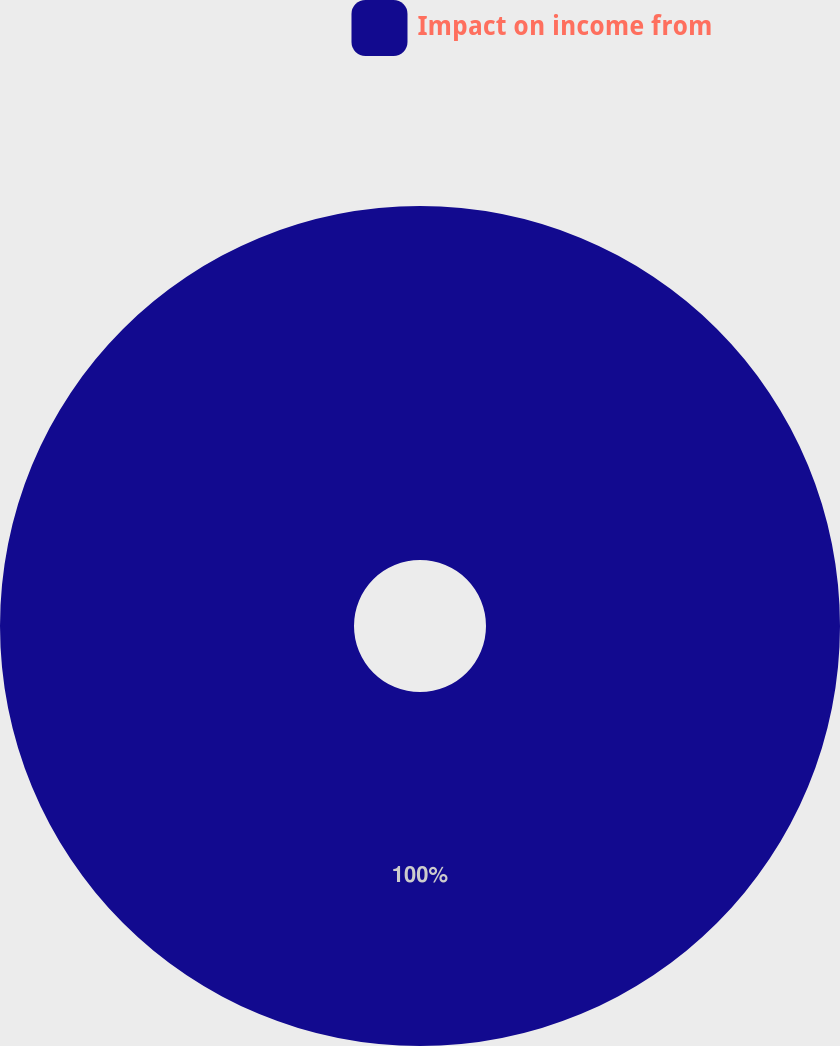Convert chart to OTSL. <chart><loc_0><loc_0><loc_500><loc_500><pie_chart><fcel>Impact on income from<nl><fcel>100.0%<nl></chart> 